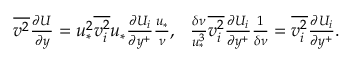Convert formula to latex. <formula><loc_0><loc_0><loc_500><loc_500>\begin{array} { r } { \overline { { v ^ { 2 } } } \frac { \partial U } { \partial y } = u _ { * } ^ { 2 } \overline { { v _ { i } ^ { 2 } } } u _ { * } \frac { \partial U _ { i } } { \partial y ^ { + } } \frac { u _ { * } } { \nu } , \quad f r a c { \delta \nu } { u _ { * } ^ { 3 } } \overline { { v _ { i } ^ { 2 } } } \frac { \partial U _ { i } } { \partial y ^ { + } } \frac { 1 } { \delta \nu } = \overline { { v _ { i } ^ { 2 } } } \frac { \partial U _ { i } } { \partial y ^ { + } } . } \end{array}</formula> 